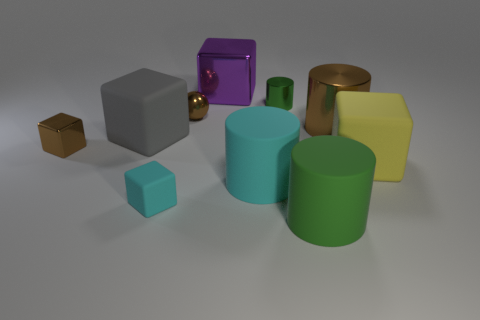Is the number of matte cylinders that are behind the purple metal object the same as the number of big rubber cylinders that are behind the small cyan matte object?
Offer a terse response. No. There is a green cylinder in front of the brown ball; is its size the same as the rubber cylinder that is behind the tiny rubber thing?
Offer a very short reply. Yes. What is the shape of the green thing that is in front of the big yellow cube in front of the large brown thing that is right of the big cyan rubber thing?
Offer a terse response. Cylinder. Is there anything else that has the same material as the cyan block?
Your answer should be compact. Yes. There is a green rubber thing that is the same shape as the tiny green metallic object; what is its size?
Your answer should be compact. Large. The cylinder that is in front of the tiny brown ball and behind the big yellow cube is what color?
Offer a very short reply. Brown. Do the large green thing and the green object that is behind the big cyan cylinder have the same material?
Offer a terse response. No. Is the number of large matte cylinders behind the large gray matte object less than the number of big purple metal things?
Provide a short and direct response. Yes. What number of other objects are the same shape as the big yellow object?
Your response must be concise. 4. Is there any other thing that is the same color as the small ball?
Offer a very short reply. Yes. 